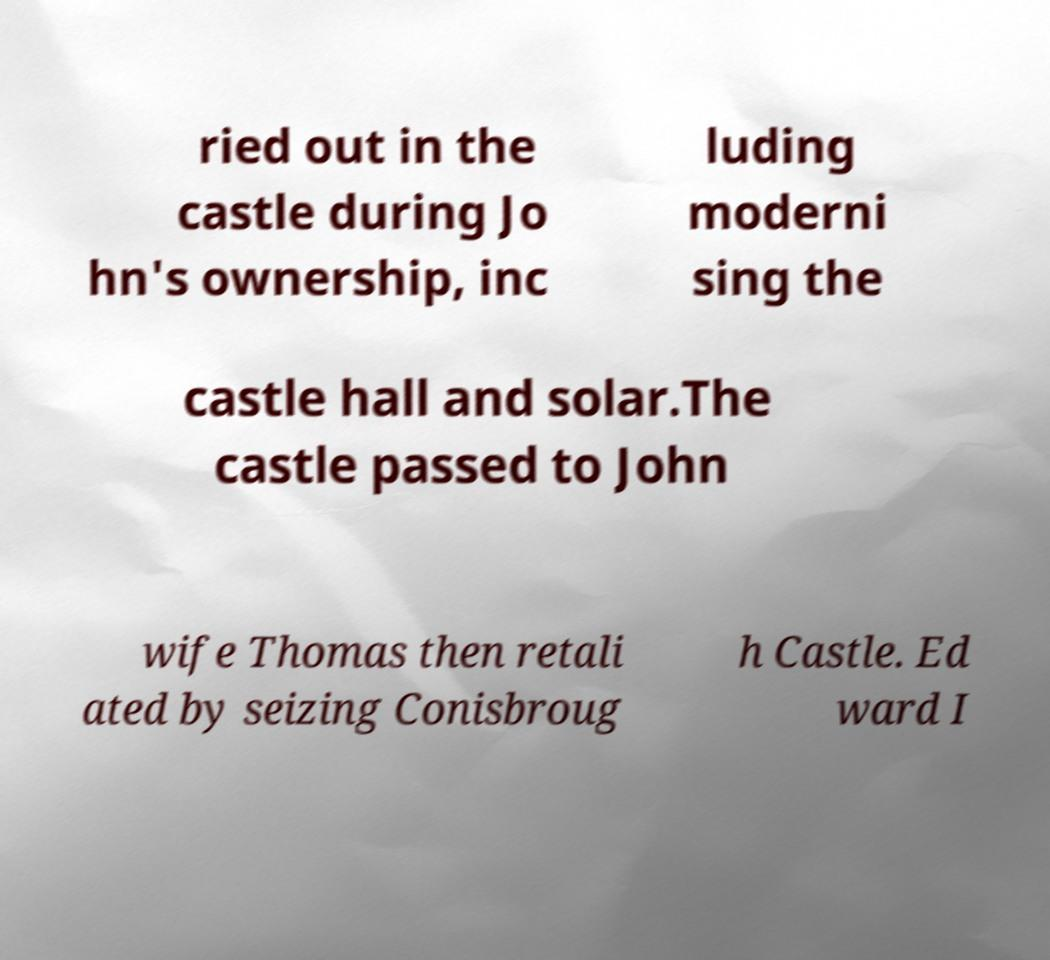Please identify and transcribe the text found in this image. ried out in the castle during Jo hn's ownership, inc luding moderni sing the castle hall and solar.The castle passed to John wife Thomas then retali ated by seizing Conisbroug h Castle. Ed ward I 